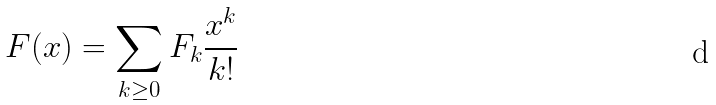Convert formula to latex. <formula><loc_0><loc_0><loc_500><loc_500>F ( x ) = \sum _ { k \geq 0 } F _ { k } \frac { x ^ { k } } { k ! }</formula> 